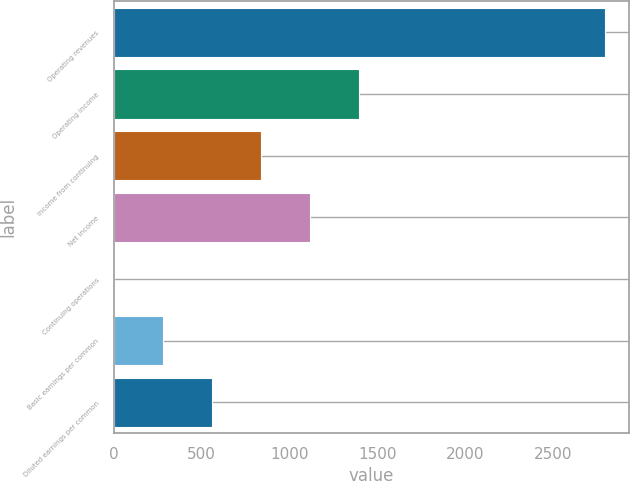Convert chart to OTSL. <chart><loc_0><loc_0><loc_500><loc_500><bar_chart><fcel>Operating revenues<fcel>Operating income<fcel>Income from continuing<fcel>Net income<fcel>Continuing operations<fcel>Basic earnings per common<fcel>Diluted earnings per common<nl><fcel>2790<fcel>1395.38<fcel>837.54<fcel>1116.46<fcel>0.75<fcel>279.68<fcel>558.61<nl></chart> 